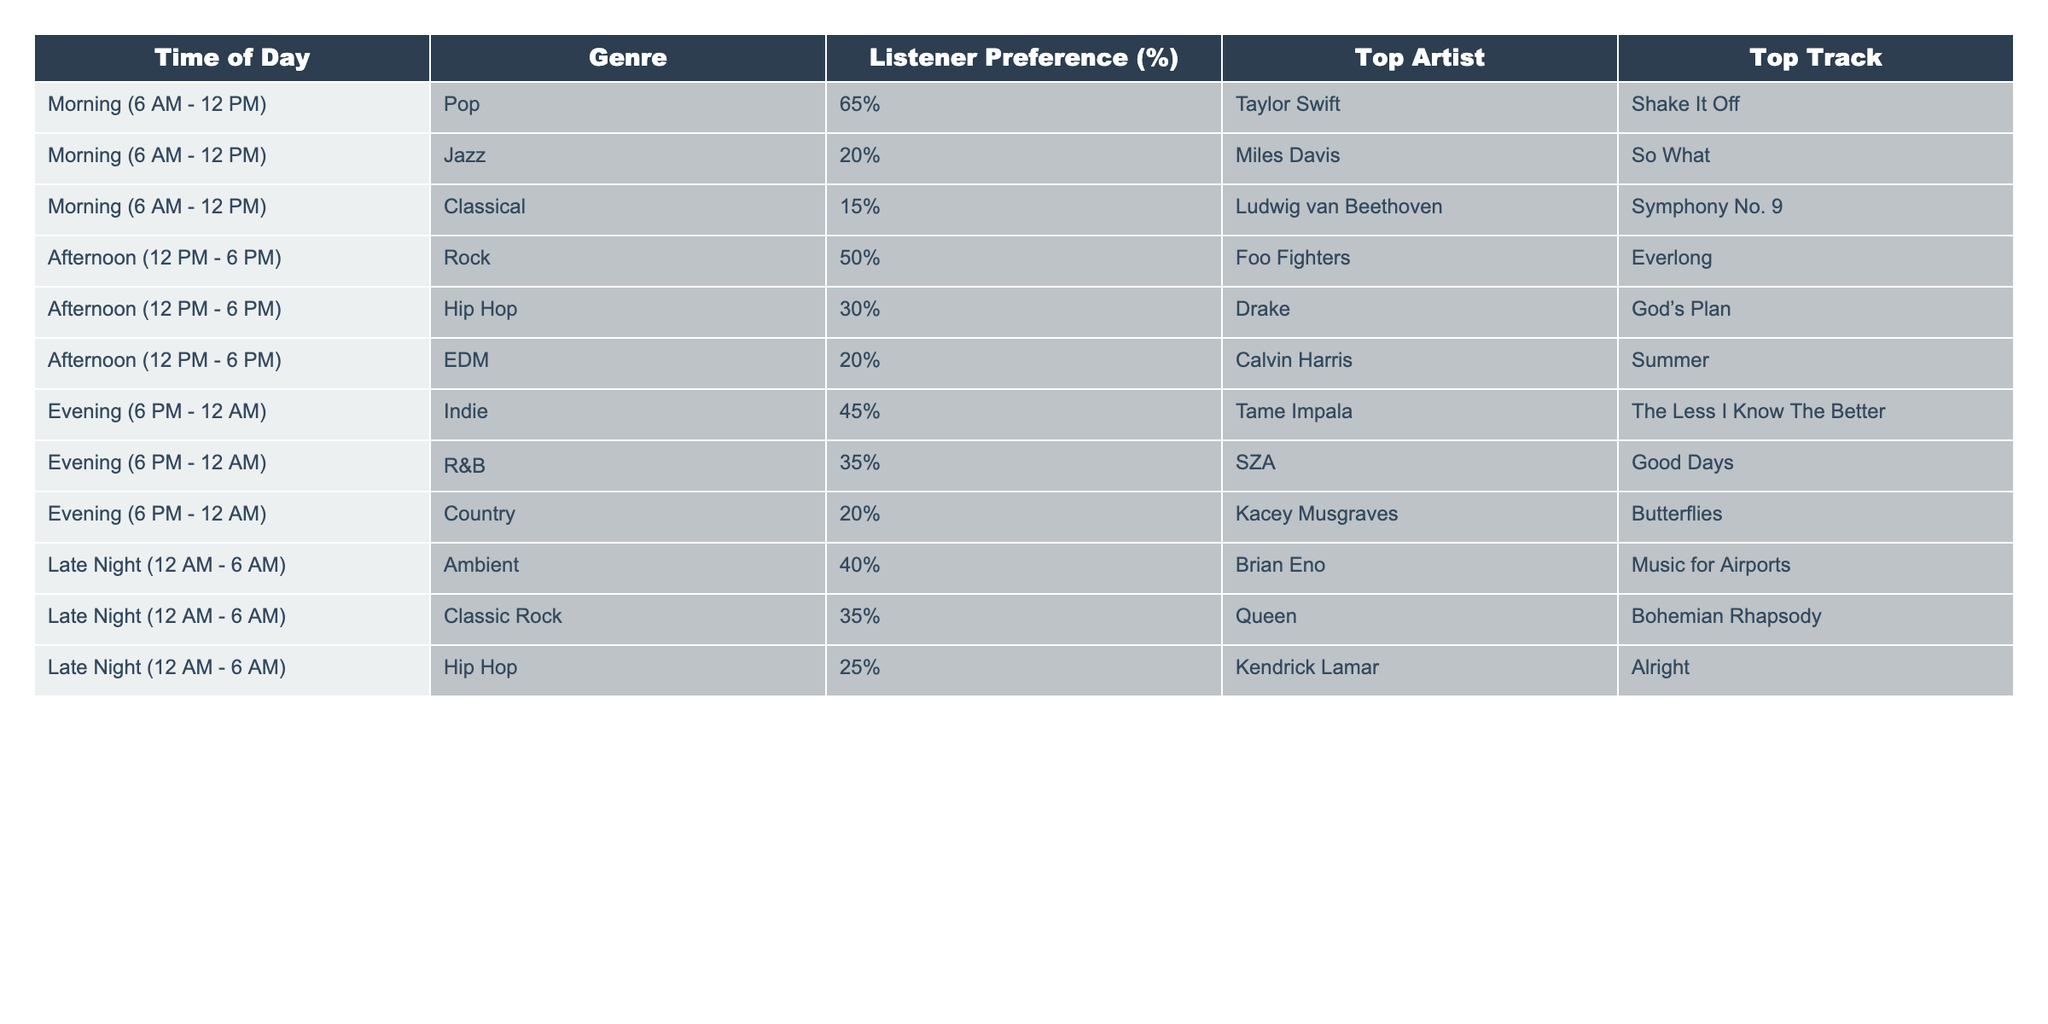What genre do listeners prefer the most in the morning? In the morning section, Pop has the highest listener preference percentage at **65%**, while Jazz and Classical have **20%** and **15%** respectively.
Answer: Pop What is the top track for the R&B genre during the evening? The evening R&B genre has **SZA** as the top artist and **Good Days** as the top track.
Answer: Good Days Which genre has the lowest preference in the afternoon? In the afternoon, EDM has the lowest listener preference at **20%**, compared to Rock at **50%** and Hip Hop at **30%**.
Answer: EDM What is the total listener preference percentage for genres in the late night? In the late night, the preferences are Ambient (**40%**), Classic Rock (**35%**), and Hip Hop (**25%**). Adding these gives **40 + 35 + 25 = 100%**.
Answer: 100% Does Hip Hop have a better preference in the afternoon compared to the evening? In the afternoon, Hip Hop has a **30%** preference, while in the evening it has a **25%** preference. Therefore, Hip Hop is more preferred in the afternoon.
Answer: Yes Which genre is associated with the most listener engagement at night? The most preferred genre during the late night is Ambient at **40%**, which is higher than both Classic Rock at **35%** and Hip Hop at **25%**.
Answer: Ambient What is the difference in listener preference for Pop in the morning compared to Rock in the afternoon? In the morning, Pop has **65%** preference, while Rock in the afternoon has **50%**. The difference is **65 - 50 = 15** percentage points.
Answer: 15 Which top artist has the lowest listener preference in the morning? In the morning, Classical is the lowest with **15%** preference, and its top artist is **Ludwig van Beethoven**.
Answer: Ludwig van Beethoven What genre dominates listener preferences in the evening hours? The evening preferences show that Indie at **45%** has the highest listener preference, dominating the evening.
Answer: Indie What genre is most popular during the late night? Among the late night genres, Ambient has the highest preference at **40%**, followed by Classic Rock and Hip Hop.
Answer: Ambient 